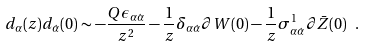Convert formula to latex. <formula><loc_0><loc_0><loc_500><loc_500>d _ { \alpha } ( z ) d _ { \dot { \alpha } } ( 0 ) \sim - \frac { Q \epsilon _ { \alpha \dot { \alpha } } } { z ^ { 2 } } - \frac { 1 } { z } \delta _ { \alpha \dot { \alpha } } \partial W ( 0 ) - \frac { 1 } { z } \sigma ^ { 1 } _ { \alpha \dot { \alpha } } \partial \bar { Z } ( 0 ) \ .</formula> 